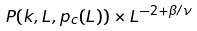Convert formula to latex. <formula><loc_0><loc_0><loc_500><loc_500>P ( k , L , p _ { c } ( L ) ) \times L ^ { - 2 + \beta / \nu }</formula> 